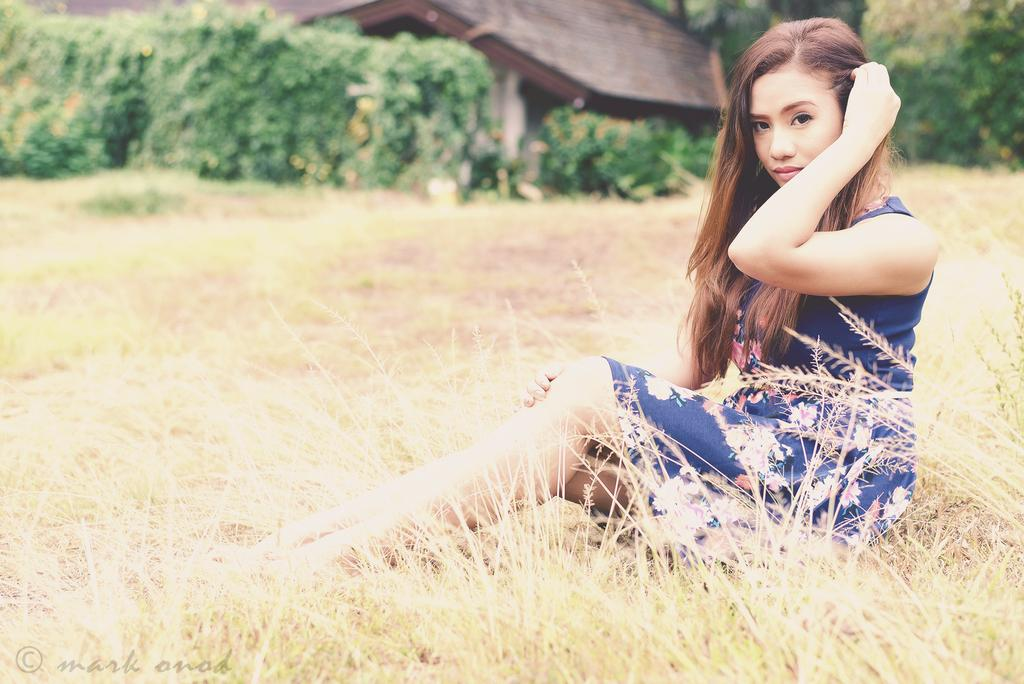Who is the main subject in the image? There is a woman in the image. What is the woman's location in the image? The woman is standing in the grass. What can be seen in the background of the image? There are trees and a house in the background of the image. What type of stew is the woman cooking in the image? There is no stew present in the image; the woman is standing in the grass. What type of beam is supporting the house in the background? There is no information about the type of beam supporting the house in the image. 